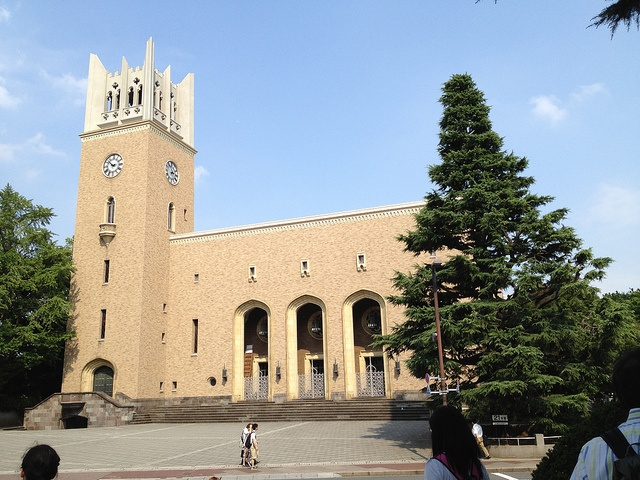Describe the objects in this image and their specific colors. I can see people in lightblue, black, and gray tones, people in lightblue, black, gray, and white tones, backpack in lightblue, black, gray, and darkblue tones, people in lightblue, black, gray, darkgray, and maroon tones, and people in lightblue, black, gray, tan, and ivory tones in this image. 